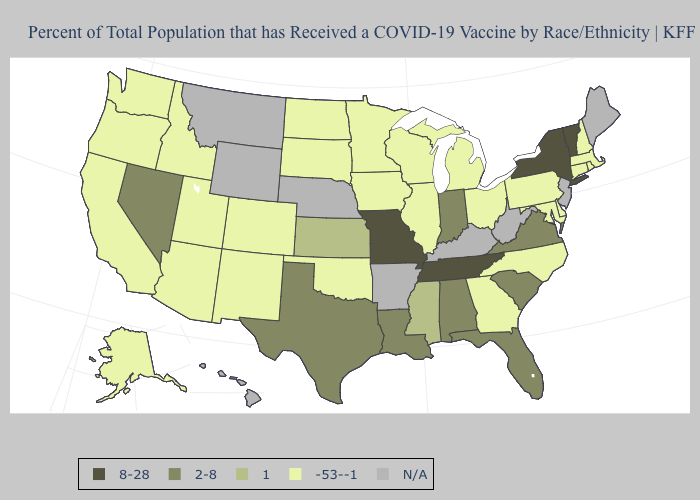Does Vermont have the highest value in the USA?
Be succinct. Yes. Among the states that border South Carolina , which have the highest value?
Keep it brief. Georgia, North Carolina. Which states have the lowest value in the USA?
Quick response, please. Alaska, Arizona, California, Colorado, Connecticut, Delaware, Georgia, Idaho, Illinois, Iowa, Maryland, Massachusetts, Michigan, Minnesota, New Hampshire, New Mexico, North Carolina, North Dakota, Ohio, Oklahoma, Oregon, Pennsylvania, Rhode Island, South Dakota, Utah, Washington, Wisconsin. What is the highest value in states that border Minnesota?
Give a very brief answer. -53--1. Name the states that have a value in the range 1?
Short answer required. Kansas, Mississippi. Among the states that border Nebraska , which have the highest value?
Write a very short answer. Missouri. What is the value of North Dakota?
Quick response, please. -53--1. Does Utah have the lowest value in the USA?
Keep it brief. Yes. What is the lowest value in the USA?
Be succinct. -53--1. What is the highest value in states that border Louisiana?
Keep it brief. 2-8. Does the map have missing data?
Give a very brief answer. Yes. What is the value of Pennsylvania?
Give a very brief answer. -53--1. Does the map have missing data?
Answer briefly. Yes. What is the value of Arkansas?
Be succinct. N/A. Name the states that have a value in the range 8-28?
Quick response, please. Missouri, New York, Tennessee, Vermont. 